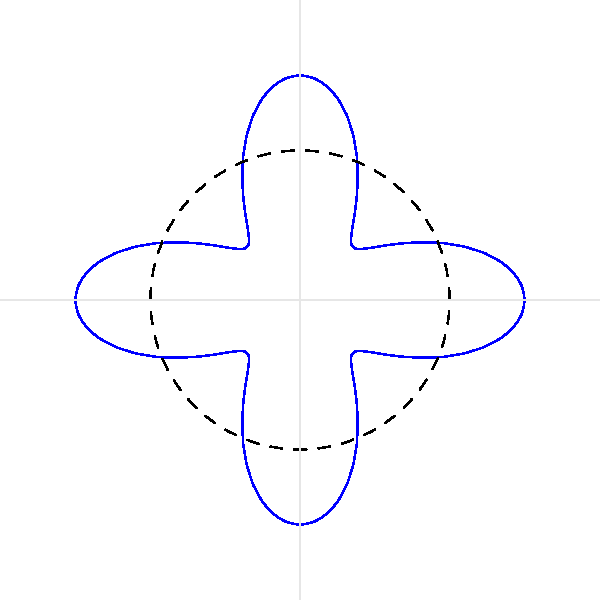Imagine you're designing a colorful pinwheel toy for your outdoor adventures. The shape of each blade can be described by the polar equation $r = 2 + \cos(4\theta)$. How many petals or blades does your pinwheel have? Let's explore this step-by-step:

1) In polar equations, the number of petals is often determined by the coefficient of $\theta$ inside the cosine (or sine) function.

2) Our equation is $r = 2 + \cos(4\theta)$.

3) The important part is $\cos(4\theta)$. The coefficient of $\theta$ is 4.

4) For cosine functions in polar equations:
   - If the coefficient is even (like in our case, 4), the number of petals equals the coefficient.
   - If the coefficient is odd, the number of petals is twice the coefficient.

5) Since our coefficient is 4, which is even, the pinwheel will have 4 petals or blades.

6) We can also think about this intuitively: the cosine function repeats every $2\pi$. With $4\theta$, it will repeat 4 times as we go around a full circle, creating 4 petals.

7) Looking at the graph, we can count and confirm that there are indeed 4 petals or blades.
Answer: 4 blades 